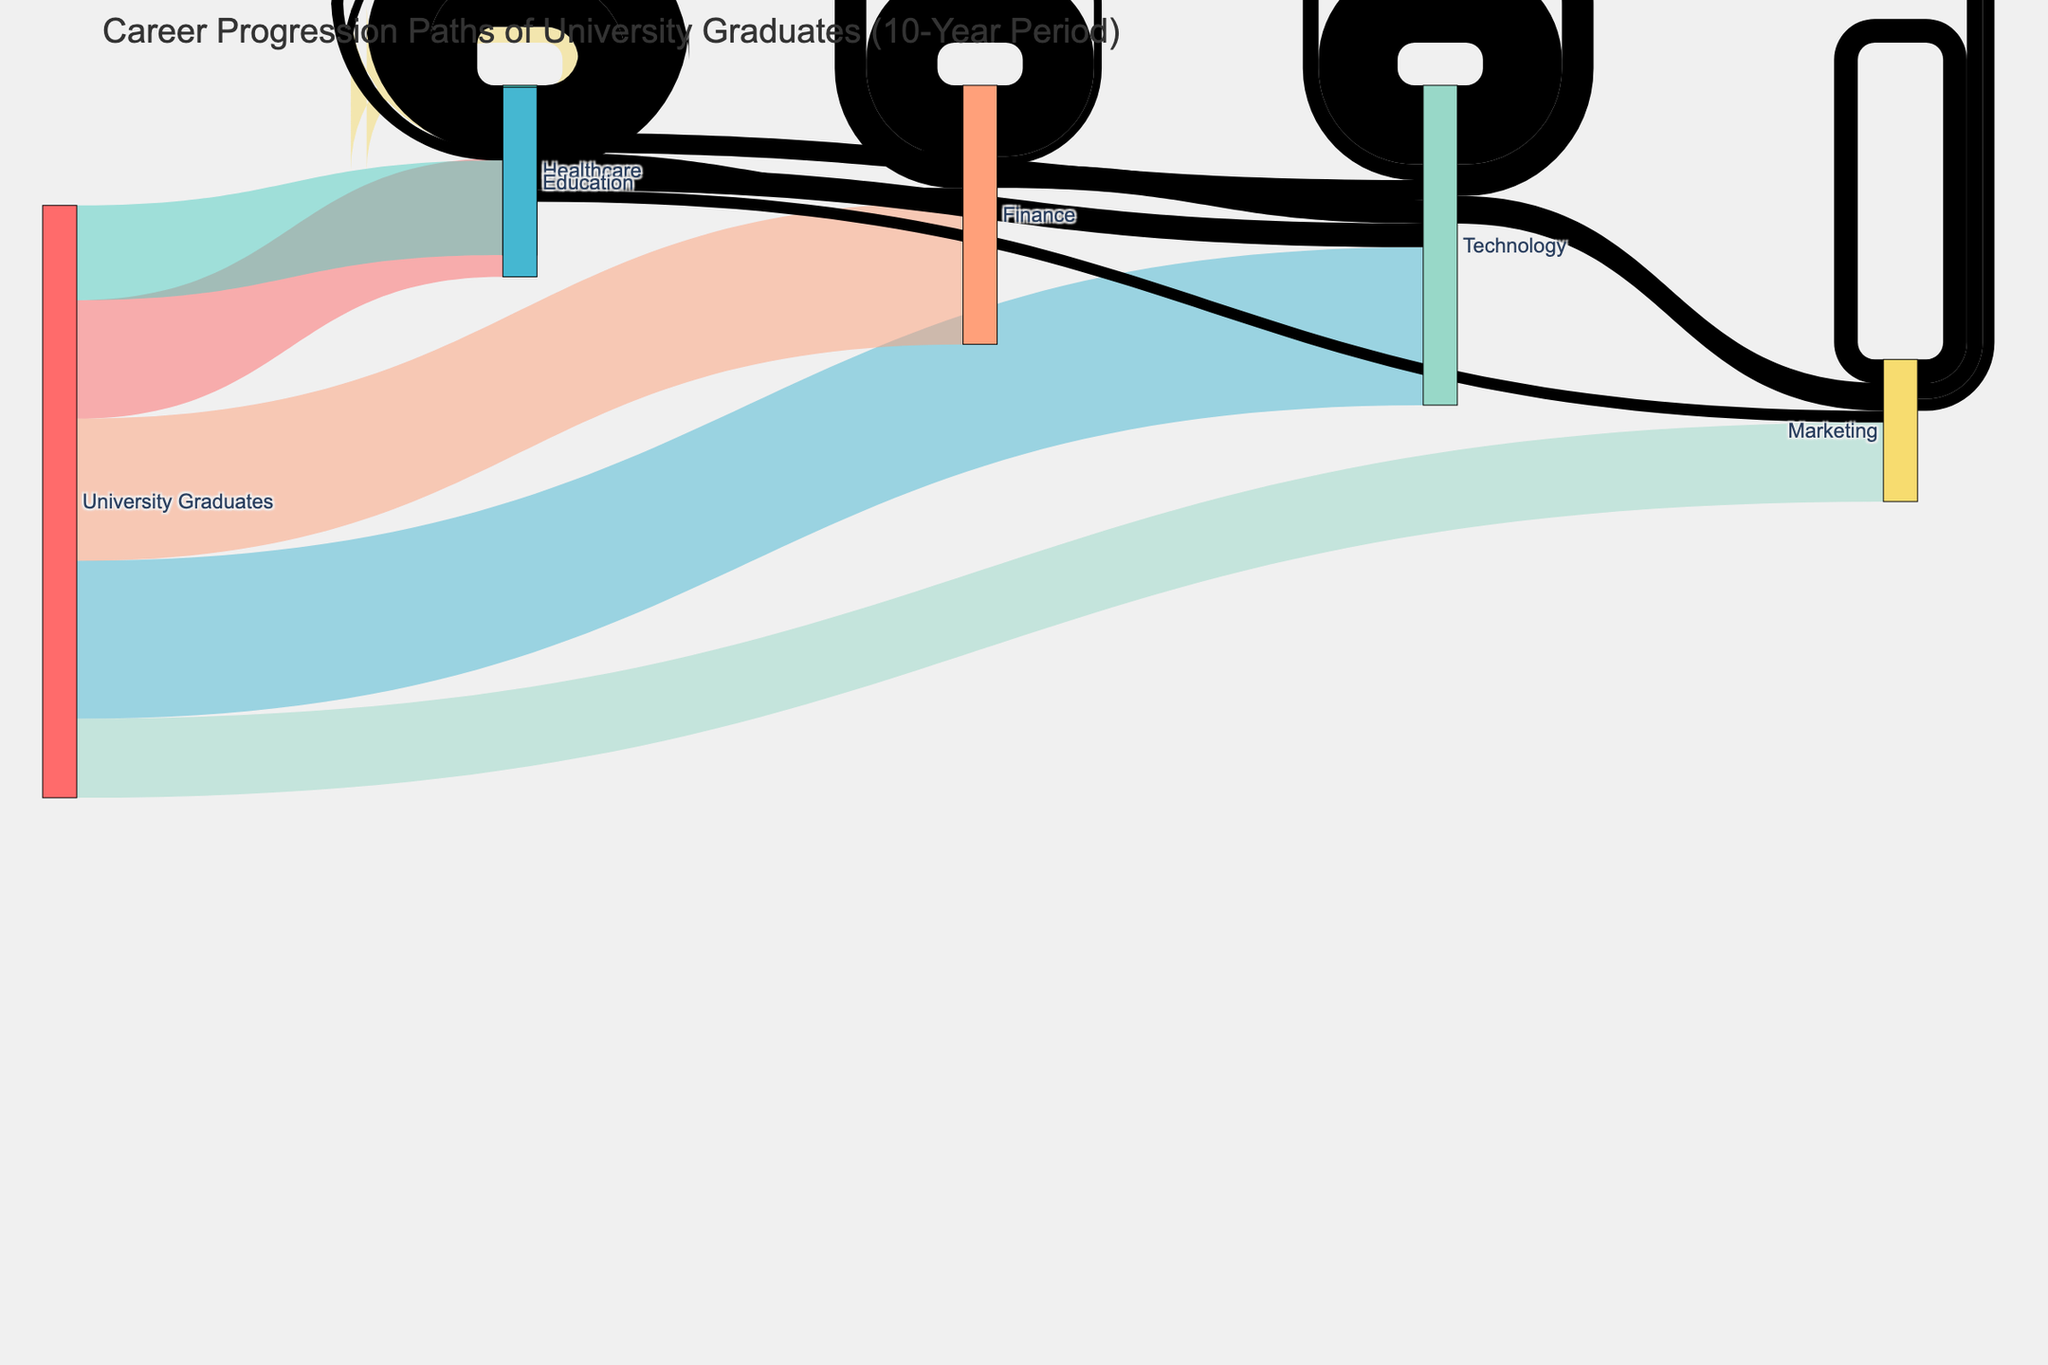What is the title of the figure? The title of the figure is typically displayed at the top and provides a summary of what the diagram is about. In this case, it's "Career Progression Paths of University Graduates (10-Year Period)"
Answer: Career Progression Paths of University Graduates (10-Year Period) Which node has the highest total inflow? To find the node with the highest total inflow, we look at the links entering each node. The "Technology" node has inflows from "University Graduates," "Education," "Healthcare," "Finance," and "Marketing" totaling 3150.
Answer: Technology How many graduates initially entered the Finance industry? Look at the flow originating from the "University Graduates" node to the "Finance" node. This value is 1800.
Answer: 1800 Which industry had the highest number of graduates transitioning to Technology from it? To answer this, we examine the links targeting "Technology." The highest individual category contributing to Technology is from "University Graduates" with a value of 2000.
Answer: University Graduates How many graduates moved from Healthcare to Finance? This can be found by locating the link between "Healthcare" and "Finance," which is 180.
Answer: 180 What is the total number of graduates that remained in the same industry after the initial job placement? We sum the self-looping links labeled with the same source and target. These values are Education (800), Healthcare (600), Technology (1000), Finance (900), and Marketing (300). Total is 3600.
Answer: 3600 Which industry saw the least transitions from University Graduates? To determine this, look at the flows from "University Graduates" and find the smallest value. "Marketing" receives 1000, the smallest among the industries listed.
Answer: Marketing How many graduates transitioned from Marketing to Technology? Identify the link connecting "Marketing" to "Technology," which is valued at 200.
Answer: 200 Which industry experienced the least outflow? We observe the outgoing flows and sums for each industry node. "Marketing" experiences an outflow of 200 (to Technology) + 150 (to Healthcare) = 350, the least compared to other industries.
Answer: Marketing 